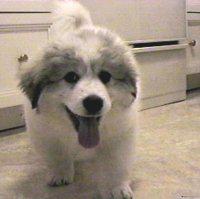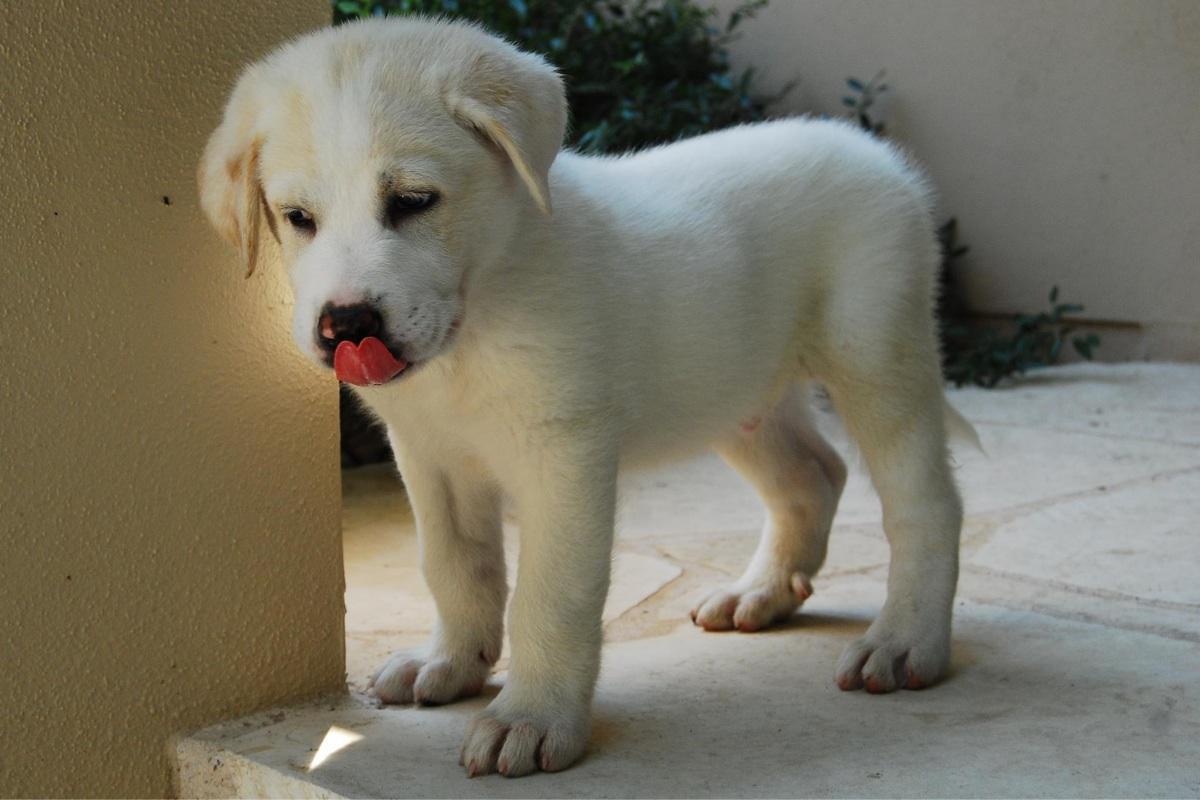The first image is the image on the left, the second image is the image on the right. Analyze the images presented: Is the assertion "One image includes at least twice as many white dogs as the other image." valid? Answer yes or no. No. The first image is the image on the left, the second image is the image on the right. Evaluate the accuracy of this statement regarding the images: "At least one dog has its mouth open.". Is it true? Answer yes or no. Yes. 